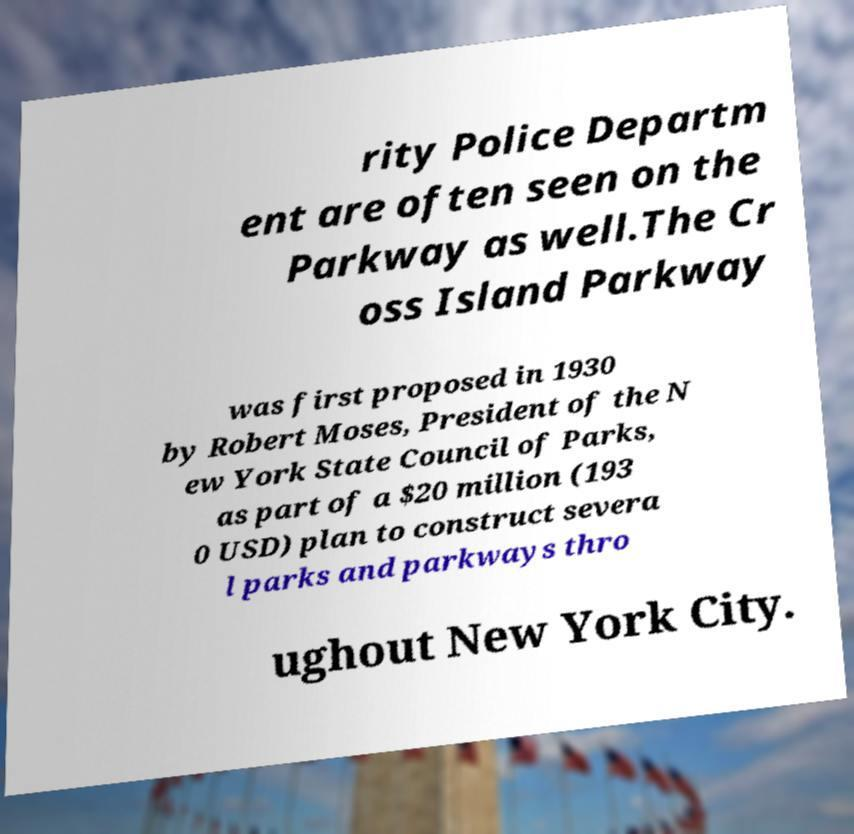Can you read and provide the text displayed in the image?This photo seems to have some interesting text. Can you extract and type it out for me? rity Police Departm ent are often seen on the Parkway as well.The Cr oss Island Parkway was first proposed in 1930 by Robert Moses, President of the N ew York State Council of Parks, as part of a $20 million (193 0 USD) plan to construct severa l parks and parkways thro ughout New York City. 